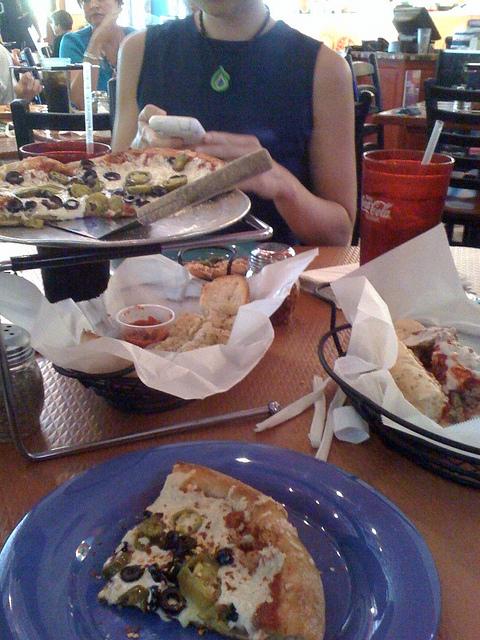What is in the thing with coke?
A. straw
B. pencil
C. spoon
D. fork
Answer with the option's letter from the given choices directly. A 